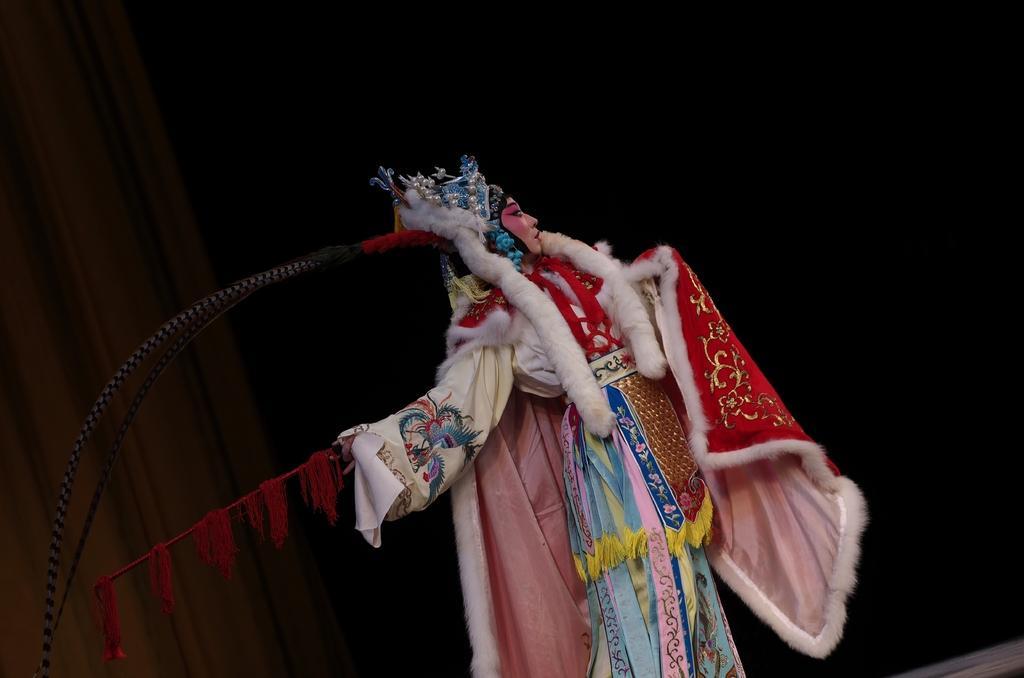Can you describe this image briefly? In the center of the image a lady is wearing cosmetics. On the left side of the image curtain is there. At the bottom right corner we can see floor. 